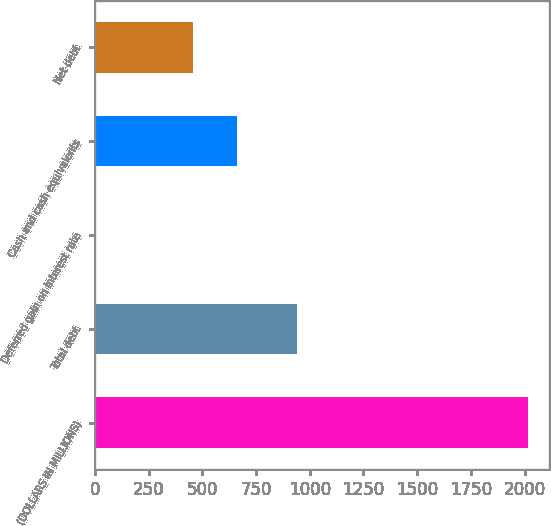Convert chart. <chart><loc_0><loc_0><loc_500><loc_500><bar_chart><fcel>(DOLLARS IN MILLIONS)<fcel>Total debt<fcel>Deferred gain on interest rate<fcel>Cash and cash equivalents<fcel>Net debt<nl><fcel>2014<fcel>942.3<fcel>5.2<fcel>659.38<fcel>458.5<nl></chart> 